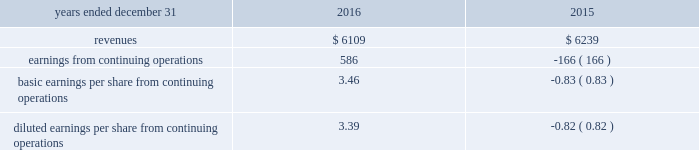The fair value of acquired property , plant and equipment , primarily network-related assets , was valued under the replacement cost method , which determines fair value based on the replacement cost of new property with similar capacity , adjusted for physical deterioration over the remaining useful life .
Goodwill is calculated as the excess of the consideration transferred over the net assets recognized and represents the future economic benefits arising from the other assets acquired that could not be individually identified and separately recognized .
Goodwill is not deductible for tax purposes .
Pro forma financial information the table presents the unaudited pro forma combined results of operations of the company and gdcl for the years ended december 31 , 2016 and december 31 , 2015 as if the acquisition of gdcl had occurred on january 1 , 2016 and january 1 , 2015 , respectively , ( in millions , except per share amounts ) : .
The company did not adjust the effects of an $ 884 million goodwill impairment charge reported in the historic results of gdcl for the year ended december 31 , 2015 on the basis that the goodwill impairment charge was not directly attributable to the acquisition of gdcl by the company .
However , this goodwill impairment charge should be highlighted as unusual and non- recurring .
The pro forma results are based on estimates and assumptions , which the company believes are reasonable .
They are not necessarily indicative of its consolidated results of operations in future periods or the results that actually would have been realized had we been a combined company during the periods presented .
The pro forma results include adjustments primarily related to amortization of acquired intangible assets , depreciation , interest expense , and transaction costs expensed during the period .
Other acquisitions on november 18 , 2014 , the company completed the acquisition of an equipment provider for a purchase price of $ 22 million .
During the year ended december 31 , 2015 , the company completed the purchase accounting for this acquisition , recognizing $ 6 million of goodwill and $ 12 million of identifiable intangible assets .
These identifiable intangible assets were classified as completed technology to be amortized over five years .
During the year ended december 31 , 2015 , the company completed the acquisitions of two providers of public safety software-based solutions for an aggregate purchase price of $ 50 million , recognizing an additional $ 31 million of goodwill , $ 22 million of identifiable intangible assets , and $ 3 million of acquired liabilities related to these acquisitions .
The $ 22 million of identifiable intangible assets were classified as : ( i ) $ 11 million completed technology , ( ii ) $ 8 million customer-related intangibles , and ( iii ) $ 3 million of other intangibles .
These intangible assets will be amortized over periods ranging from five to ten years .
On november 10 , 2016 , the company completed the acquisition of spillman technologies , a provider of comprehensive law enforcement and public safety software solutions , for a gross purchase price of $ 217 million .
As a result of the acquisition , the company recognized $ 140 million of goodwill , $ 115 million of identifiable intangible assets , and $ 38 million of acquired liabilities .
The identifiable intangible assets were classified as $ 49 million of completed technology , $ 59 million of customer- related intangibles , and $ 7 million of other intangibles and will be amortized over a period of seven to ten years .
As of december 31 , 2016 , the purchase accounting is not yet complete .
The final allocation may include : ( i ) changes in fair values of acquired goodwill and ( ii ) changes to assets and liabilities .
During the year ended december 31 , 2016 , the company completed the acquisition of several software and service-based providers for a total of $ 30 million , recognizing $ 6 million of goodwill , $ 15 million of intangible assets , and $ 9 million of tangible net assets related to the these acquisitions .
The $ 15 million of identifiable intangible assets were classified as : ( i ) $ 7 million of completed technology and ( ii ) $ 8 million of customer-related intangibles and will be amortized over a period of five years .
As of december 31 , 2016 , the purchase accounting has not been completed for one acquisition which was purchased in late 2016 .
As such , an amount of $ 11 million has been recorded within other assets as of december 31 , 2016 .
The purchase accounting is expected to be completed in the first quarter of 2017 .
The results of operations for these acquisitions have been included in the company 2019s condensed consolidated statements of operations subsequent to the acquisition date .
The pro forma effects of these acquisitions are not significant individually or in the aggregate. .
What was the profit margin in 2016? 
Computations: (586 / 6109)
Answer: 0.09592. 